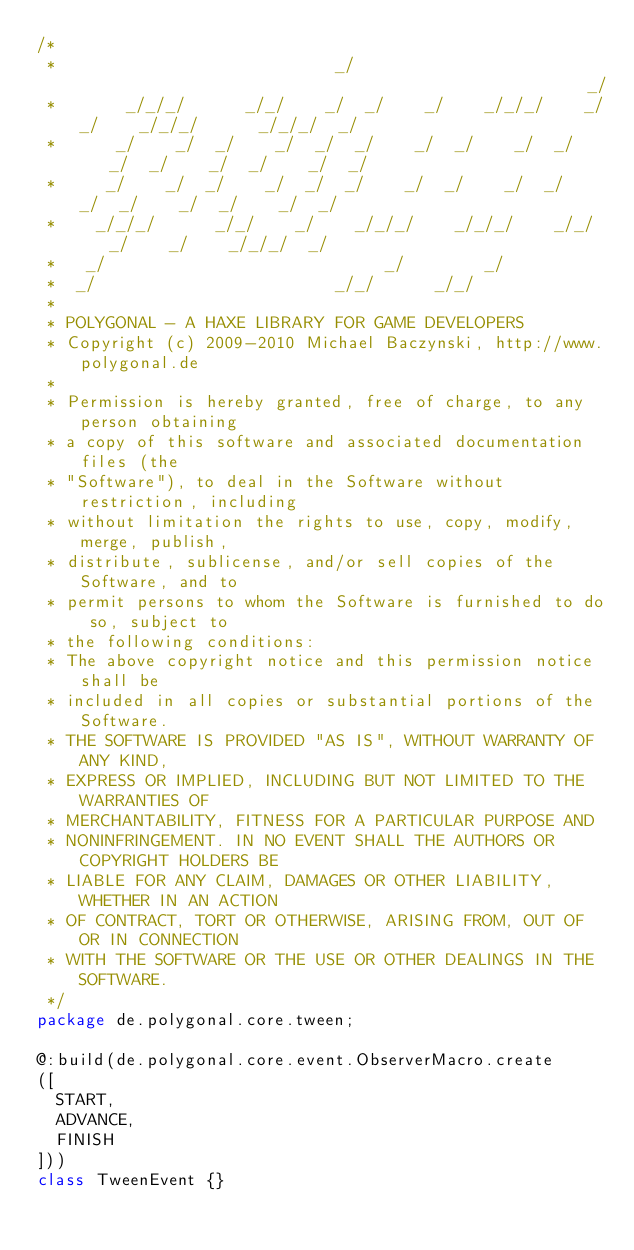Convert code to text. <code><loc_0><loc_0><loc_500><loc_500><_Haxe_>/*
 *                            _/                                                    _/   
 *       _/_/_/      _/_/    _/  _/    _/    _/_/_/    _/_/    _/_/_/      _/_/_/  _/    
 *      _/    _/  _/    _/  _/  _/    _/  _/    _/  _/    _/  _/    _/  _/    _/  _/     
 *     _/    _/  _/    _/  _/  _/    _/  _/    _/  _/    _/  _/    _/  _/    _/  _/      
 *    _/_/_/      _/_/    _/    _/_/_/    _/_/_/    _/_/    _/    _/    _/_/_/  _/       
 *   _/                            _/        _/                                          
 *  _/                        _/_/      _/_/                                             
 *                                                                                       
 * POLYGONAL - A HAXE LIBRARY FOR GAME DEVELOPERS
 * Copyright (c) 2009-2010 Michael Baczynski, http://www.polygonal.de
 *
 * Permission is hereby granted, free of charge, to any person obtaining
 * a copy of this software and associated documentation files (the
 * "Software"), to deal in the Software without restriction, including
 * without limitation the rights to use, copy, modify, merge, publish,
 * distribute, sublicense, and/or sell copies of the Software, and to
 * permit persons to whom the Software is furnished to do so, subject to
 * the following conditions:
 * The above copyright notice and this permission notice shall be
 * included in all copies or substantial portions of the Software.
 * THE SOFTWARE IS PROVIDED "AS IS", WITHOUT WARRANTY OF ANY KIND,
 * EXPRESS OR IMPLIED, INCLUDING BUT NOT LIMITED TO THE WARRANTIES OF
 * MERCHANTABILITY, FITNESS FOR A PARTICULAR PURPOSE AND
 * NONINFRINGEMENT. IN NO EVENT SHALL THE AUTHORS OR COPYRIGHT HOLDERS BE
 * LIABLE FOR ANY CLAIM, DAMAGES OR OTHER LIABILITY, WHETHER IN AN ACTION
 * OF CONTRACT, TORT OR OTHERWISE, ARISING FROM, OUT OF OR IN CONNECTION
 * WITH THE SOFTWARE OR THE USE OR OTHER DEALINGS IN THE SOFTWARE.
 */
package de.polygonal.core.tween;

@:build(de.polygonal.core.event.ObserverMacro.create
([
	START,
	ADVANCE,
	FINISH
]))
class TweenEvent {}</code> 